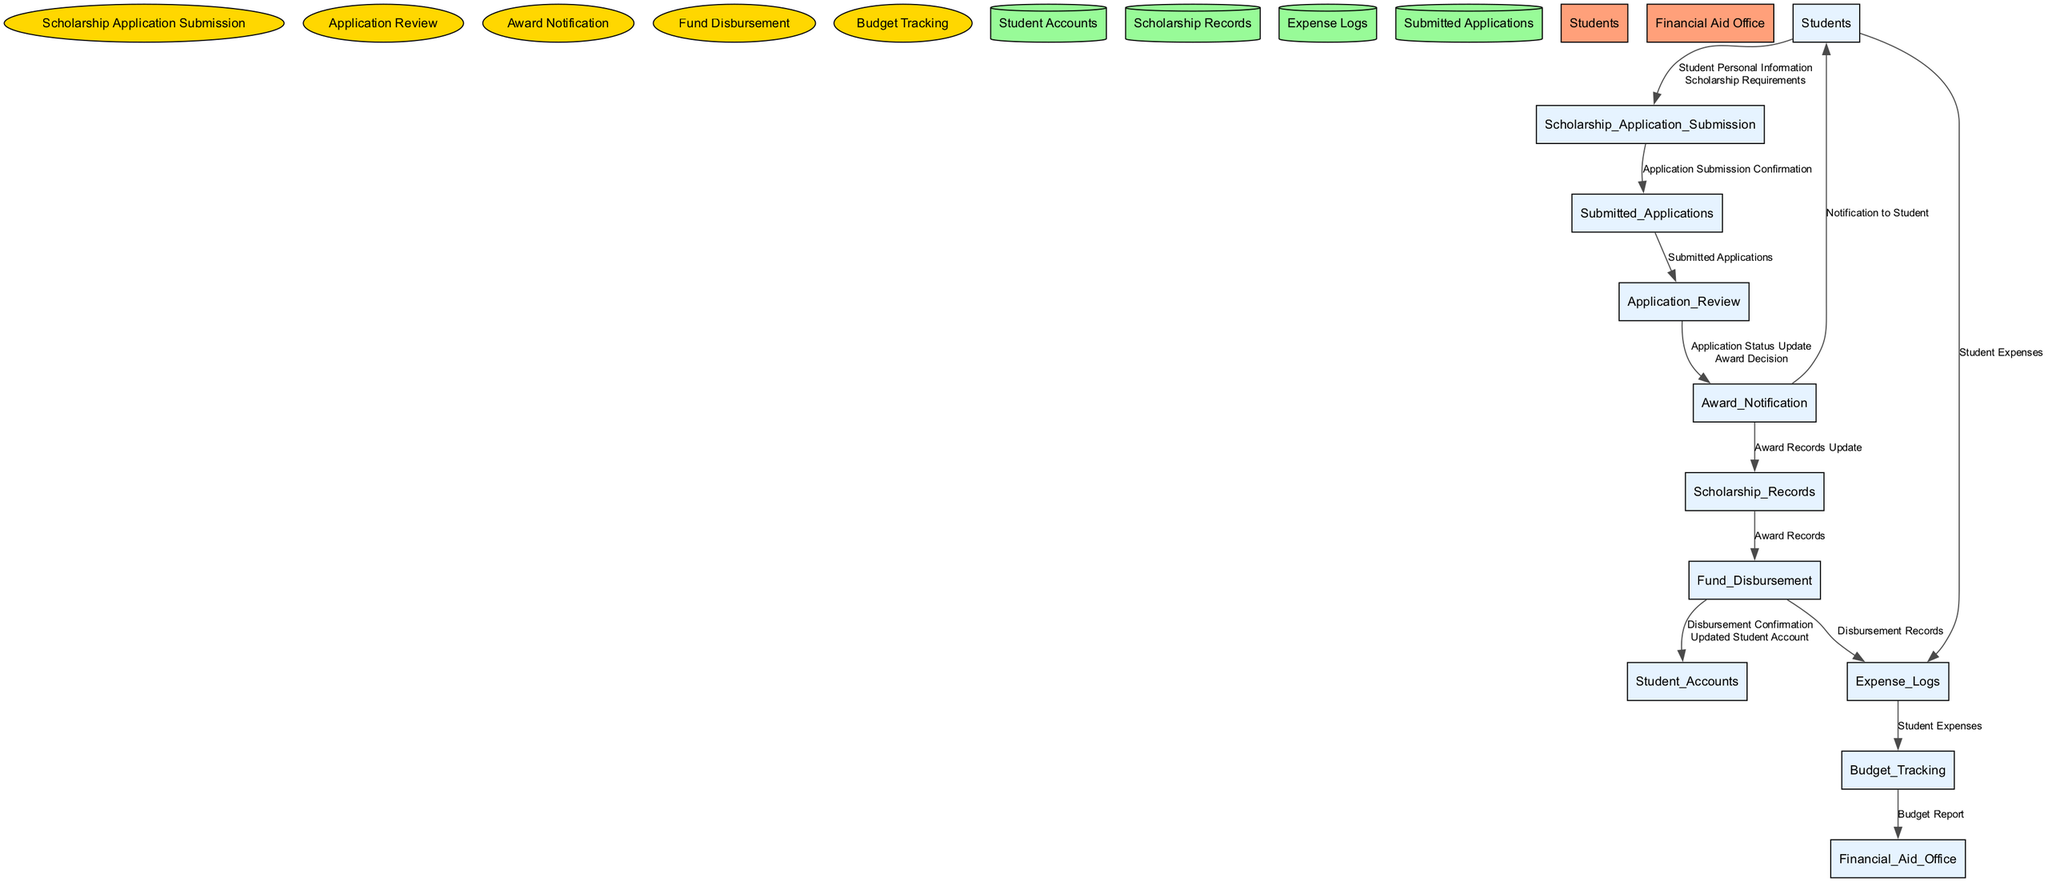What is the first process in the flow? The first process in the diagram is "Scholarship Application Submission" since it is the initial action performed by the students as they apply for scholarships.
Answer: Scholarship Application Submission How many data stores are present in the diagram? There are four data stores listed in the diagram: Student Accounts, Scholarship Records, Expense Logs, and Submitted Applications. Counting each gives a total of four data stores.
Answer: 4 What type of node is "Application Review"? "Application Review" is a process, visually represented by an ellipse shape in the diagram, which indicates that it performs actions on the submitted applications.
Answer: Process Which external entity receives the budget report? The budget report is sent to the "Financial Aid Office," as indicated by the flow from the Budget Tracking process to this external entity in the diagram.
Answer: Financial Aid Office What is the output of the "Fund Disbursement" process? The outputs of the "Fund Disbursement" process are "Disbursement Confirmation" and "Updated Student Account." Both outputs are essential as they keep the students informed and update their financial statistics respectively.
Answer: Disbursement Confirmation, Updated Student Account Which data flow connects "Students" to "Expense Logs"? The data flow that connects "Students" to "Expense Logs" contains the data "Student Expenses," meaning students provide information about their expenditures to this data store.
Answer: Student Expenses What follows the "Award Notification" process? After the "Award Notification" process, two things happen: it sends a notification to the Students and updates the Scholarship Records, indicating both communication and record-keeping actions follow the award notification.
Answer: Notification to Student, Award Records Update How do "Submitted Applications" impact "Application Review"? "Submitted Applications" are the input to the "Application Review," which assesses them and determines the applications' status and award decisions, showing a direct flow from the submitted applications to the review process.
Answer: Application Review 